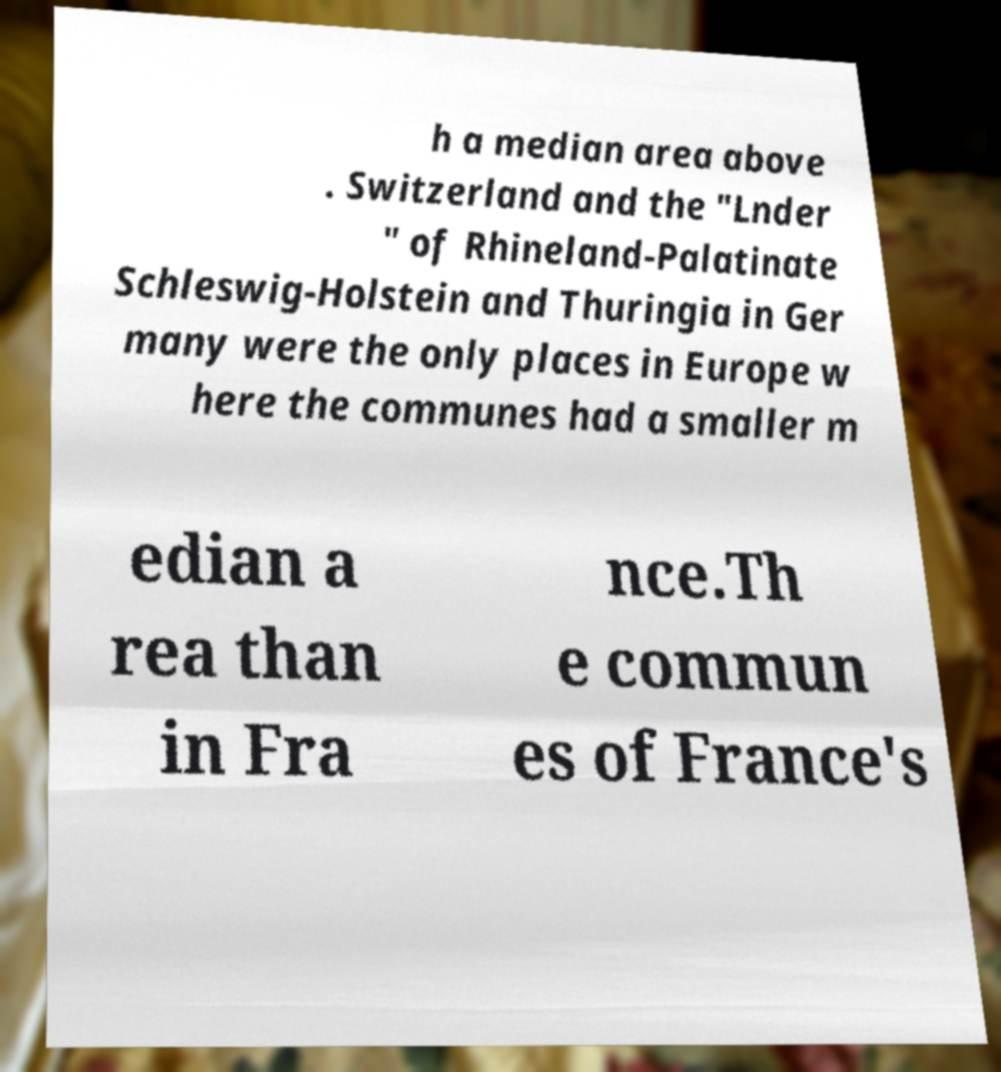Can you accurately transcribe the text from the provided image for me? h a median area above . Switzerland and the "Lnder " of Rhineland-Palatinate Schleswig-Holstein and Thuringia in Ger many were the only places in Europe w here the communes had a smaller m edian a rea than in Fra nce.Th e commun es of France's 